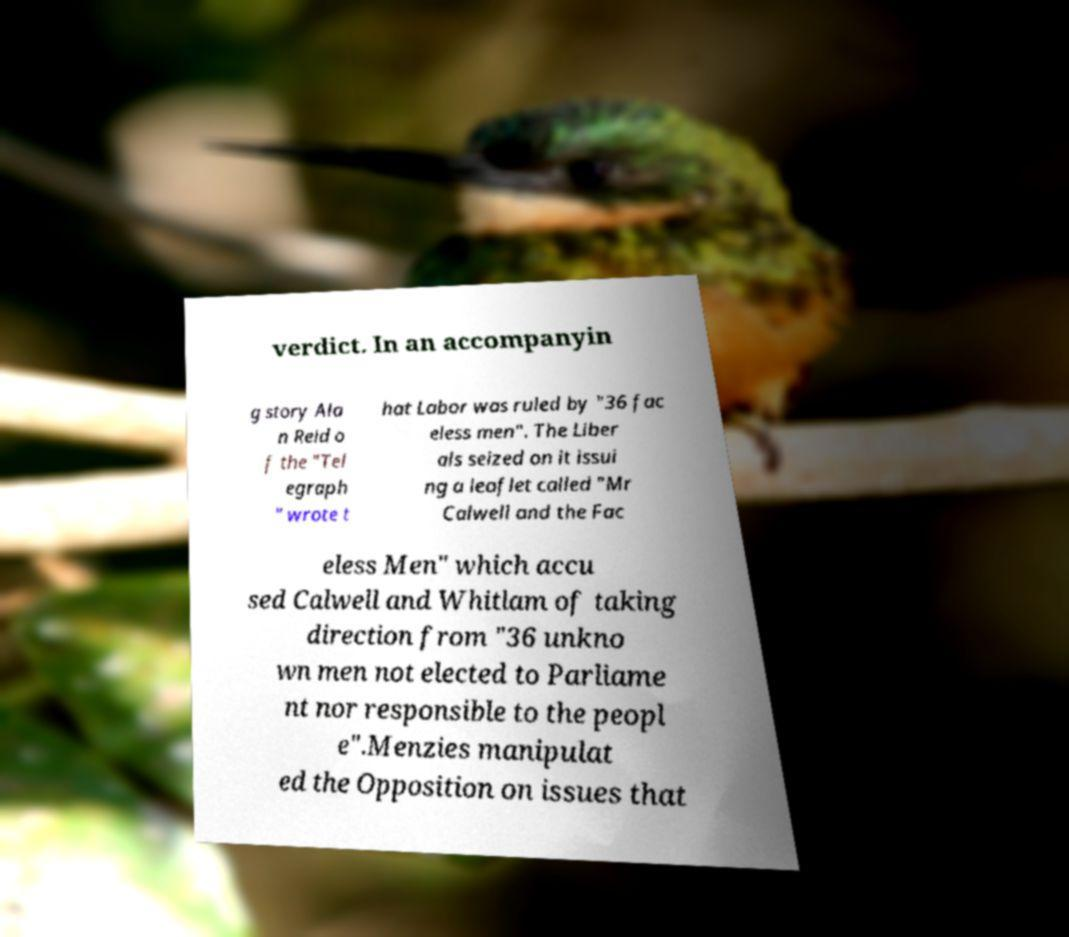Please identify and transcribe the text found in this image. verdict. In an accompanyin g story Ala n Reid o f the "Tel egraph " wrote t hat Labor was ruled by "36 fac eless men". The Liber als seized on it issui ng a leaflet called "Mr Calwell and the Fac eless Men" which accu sed Calwell and Whitlam of taking direction from "36 unkno wn men not elected to Parliame nt nor responsible to the peopl e".Menzies manipulat ed the Opposition on issues that 